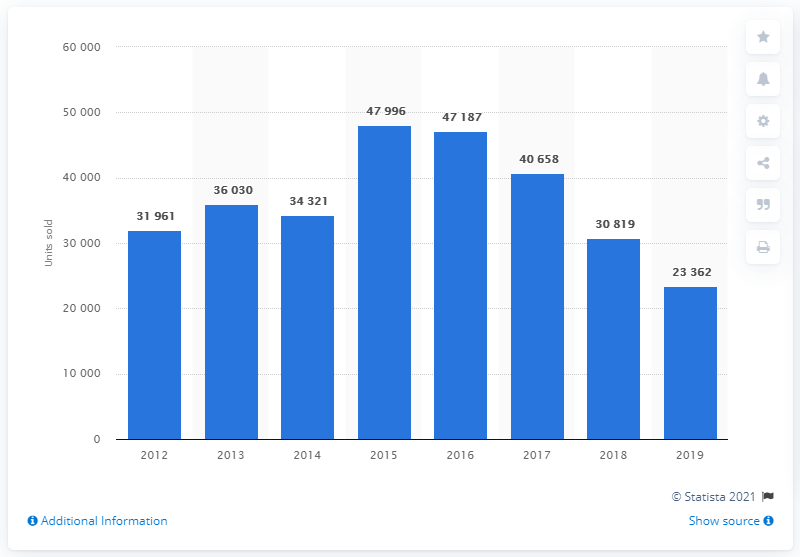Point out several critical features in this image. In 2019, Toyota sold a total of 23,362 cars in Turkey. In 2015, a total of 47,996 Toyota cars were sold in Turkey. 